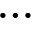<formula> <loc_0><loc_0><loc_500><loc_500>\dots</formula> 